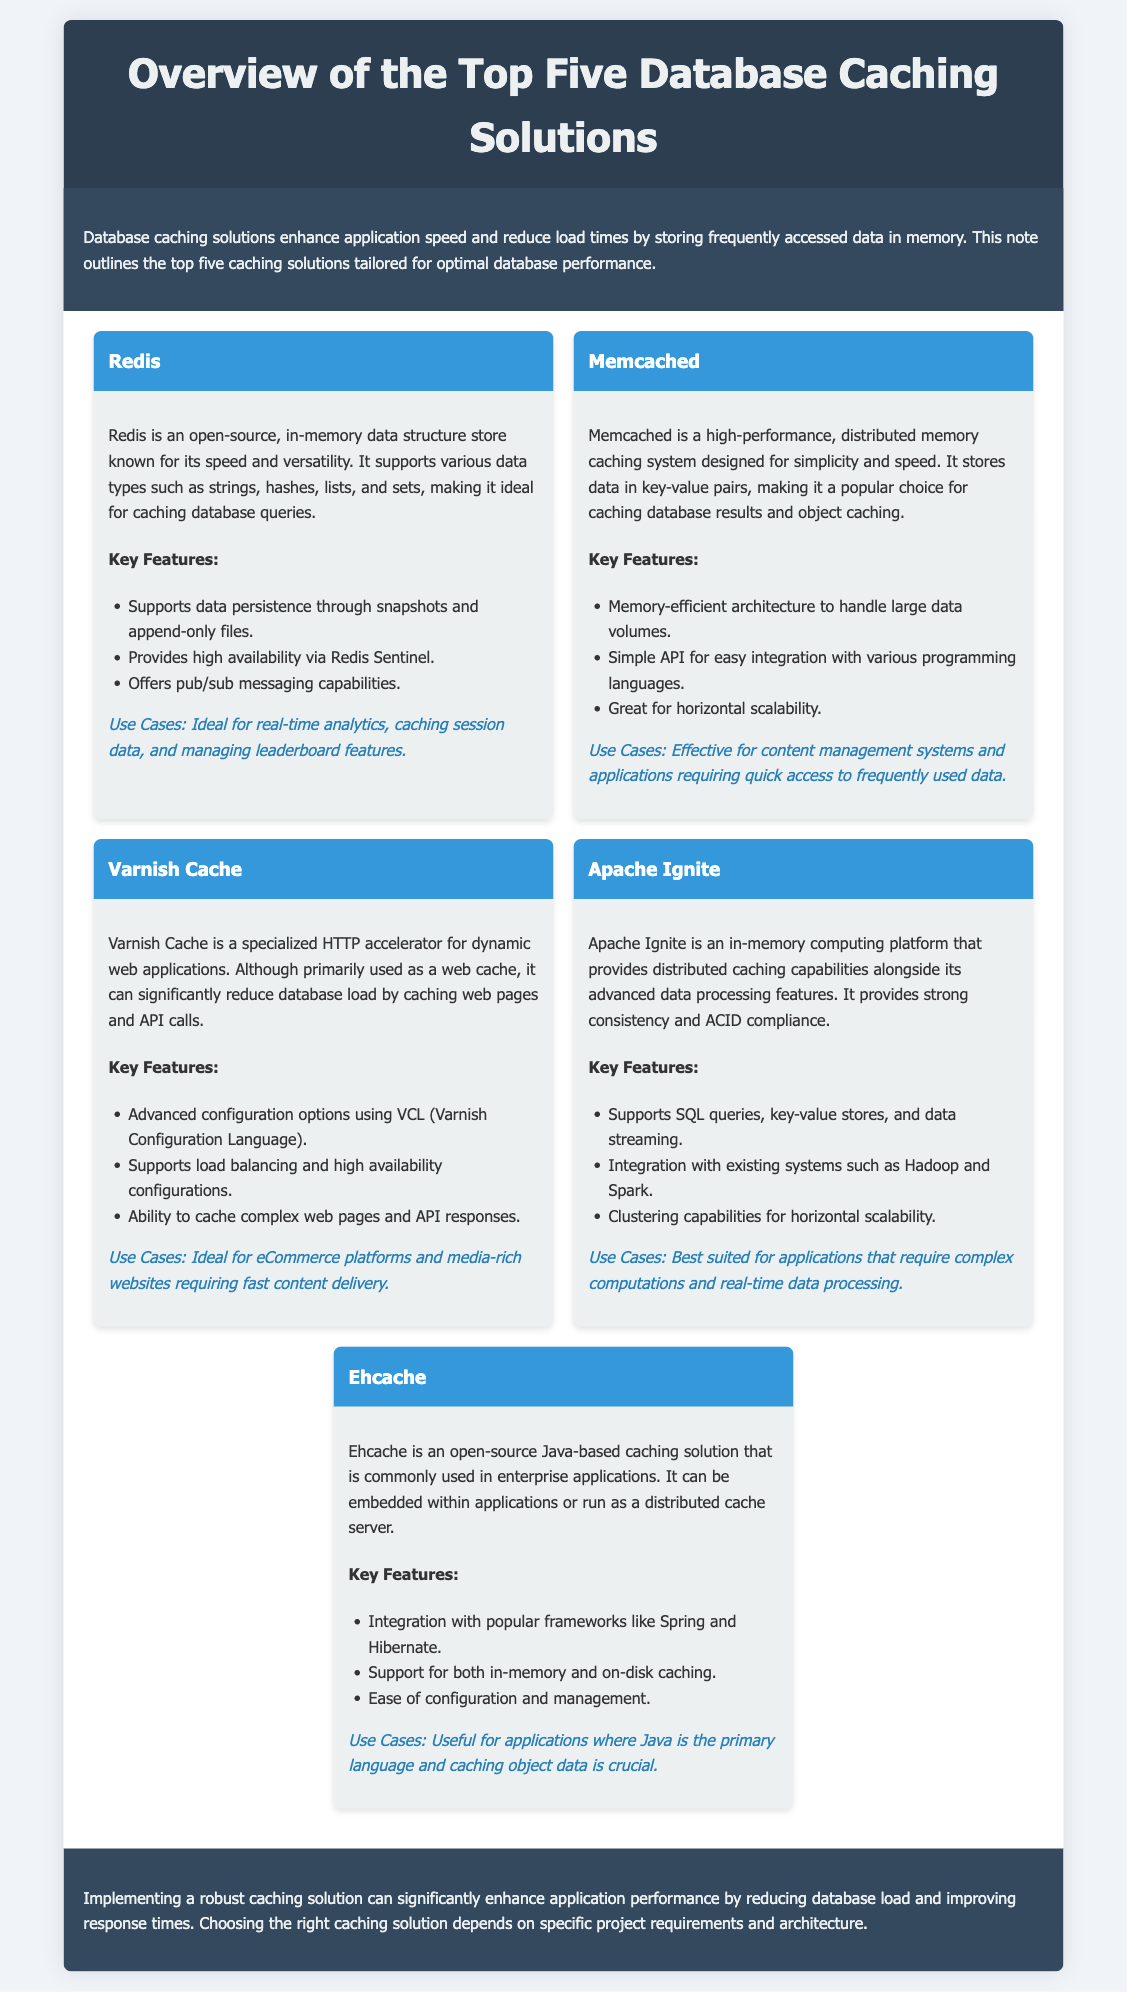What is the title of the document? The title, as indicated in the HTML code, is found within the head section.
Answer: Overview of the Top Five Database Caching Solutions How many caching solutions are detailed in the document? The document explicitly mentions that it provides an overview of five solutions, seen in the introduction.
Answer: Five What is the primary function of Redis? Redis is described in the document as a versatile data structure store ideal for caching database queries.
Answer: Caching database queries Which caching solution is best suited for eCommerce platforms? The document states that Varnish Cache is ideal for eCommerce platforms, providing a specific use case.
Answer: Varnish Cache What data structures does Redis support? The document lists the types of data structures supported by Redis in its description.
Answer: Strings, hashes, lists, and sets Which feature of Memcached makes it efficient for large data volumes? The document highlights a specific feature of Memcached related to its architecture.
Answer: Memory-efficient architecture What scripting language does Varnish Cache use for advanced configurations? The document indicates that Varnish Cache uses a specific configuration language for its advanced options.
Answer: VCL What is a use case for Ehcache? The document provides a specific context where Ehcache is useful, particularly in applications.
Answer: Caching object data 